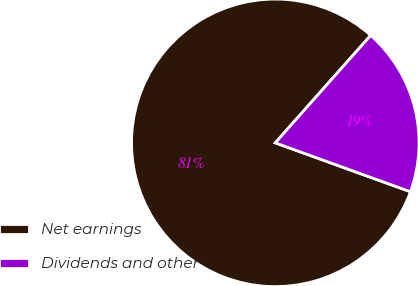<chart> <loc_0><loc_0><loc_500><loc_500><pie_chart><fcel>Net earnings<fcel>Dividends and other<nl><fcel>81.03%<fcel>18.97%<nl></chart> 